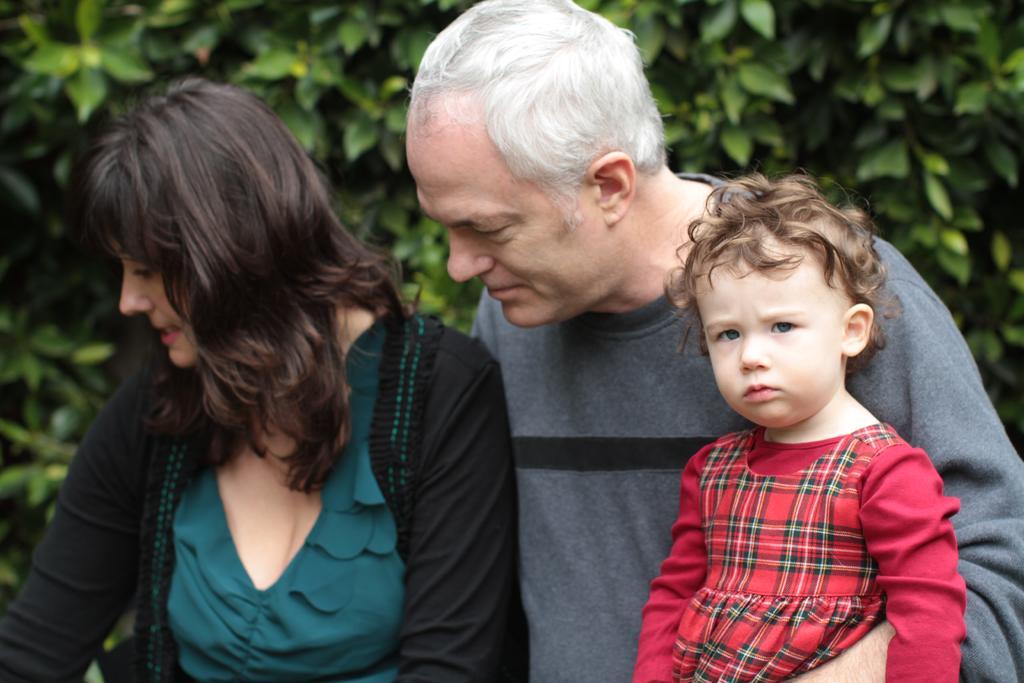Describe this image in one or two sentences. In this picture we can observe a kid, man and a woman. This kid is wearing red color dress. In the background we can observe some trees. 